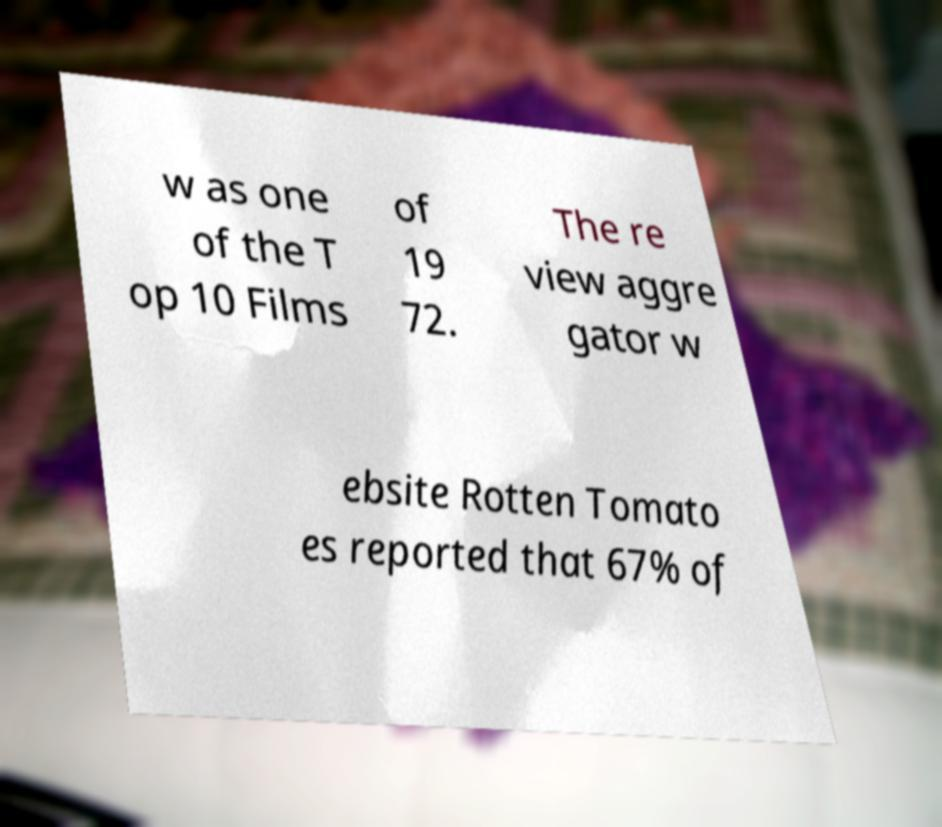Please read and relay the text visible in this image. What does it say? w as one of the T op 10 Films of 19 72. The re view aggre gator w ebsite Rotten Tomato es reported that 67% of 